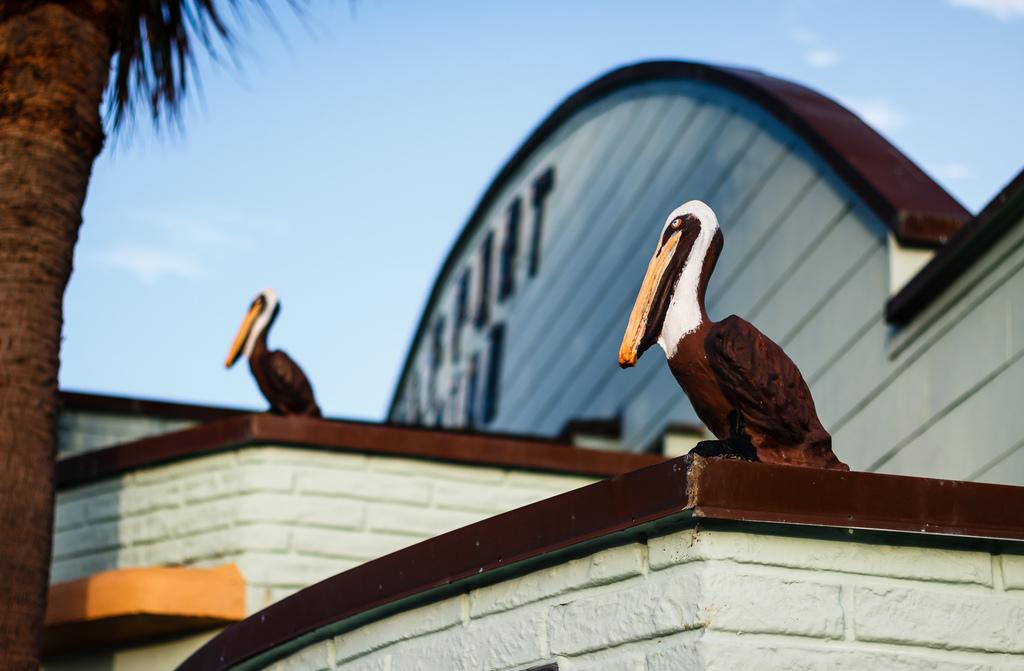What type of artwork is present on the building in the image? There are two sculptures of birds on the building. What type of plant can be seen in the image? There is a tree in the image. What can be seen in the background of the image? The sky is visible in the background of the image. Are there any beams visible in the image? There is no mention of beams in the provided facts, so we cannot determine if any are present in the image. Can you see any cobwebs on the tree in the image? There is no mention of cobwebs in the provided facts, so we cannot determine if any are present in the image. 